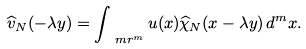<formula> <loc_0><loc_0><loc_500><loc_500>\widehat { v } _ { N } ( - \lambda y ) = \int _ { \ m r ^ { m } } u ( x ) \widehat { \chi } _ { N } ( x - \lambda y ) \, d ^ { m } x .</formula> 